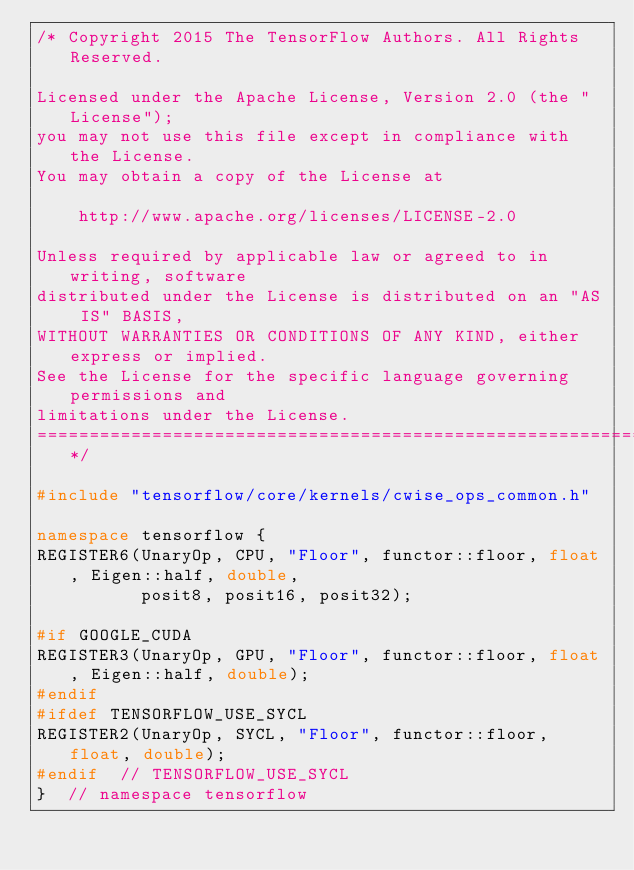Convert code to text. <code><loc_0><loc_0><loc_500><loc_500><_C++_>/* Copyright 2015 The TensorFlow Authors. All Rights Reserved.

Licensed under the Apache License, Version 2.0 (the "License");
you may not use this file except in compliance with the License.
You may obtain a copy of the License at

    http://www.apache.org/licenses/LICENSE-2.0

Unless required by applicable law or agreed to in writing, software
distributed under the License is distributed on an "AS IS" BASIS,
WITHOUT WARRANTIES OR CONDITIONS OF ANY KIND, either express or implied.
See the License for the specific language governing permissions and
limitations under the License.
==============================================================================*/

#include "tensorflow/core/kernels/cwise_ops_common.h"

namespace tensorflow {
REGISTER6(UnaryOp, CPU, "Floor", functor::floor, float, Eigen::half, double,
          posit8, posit16, posit32);

#if GOOGLE_CUDA
REGISTER3(UnaryOp, GPU, "Floor", functor::floor, float, Eigen::half, double);
#endif
#ifdef TENSORFLOW_USE_SYCL
REGISTER2(UnaryOp, SYCL, "Floor", functor::floor, float, double);
#endif  // TENSORFLOW_USE_SYCL
}  // namespace tensorflow
</code> 